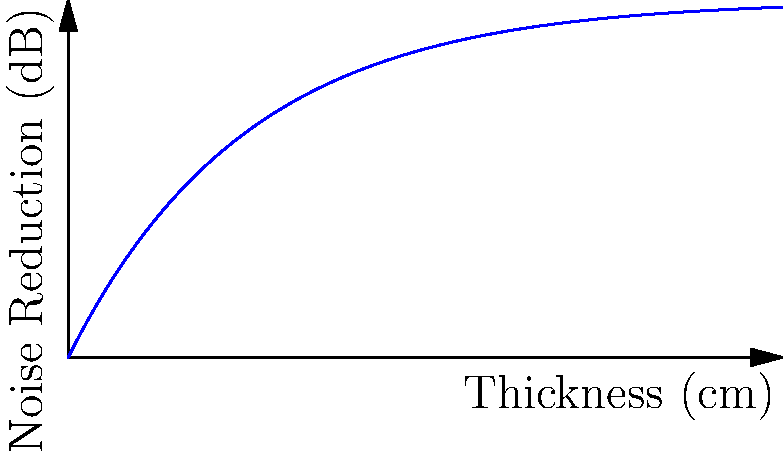A homeowner near a rail crossing wants to optimize their soundproofing. The noise reduction (in dB) achieved by a soundproofing material is given by the function $R(x) = 10(1-e^{-0.2x})$, where $x$ is the thickness of the material in centimeters. The homeowner has a budget that allows for a maximum thickness of 20 cm. What thickness should be used to maximize the rate of noise reduction per unit thickness? To find the optimal thickness, we need to maximize the rate of noise reduction per unit thickness. This is equivalent to finding the point where the second derivative of $R(x)$ is zero.

Step 1: Find the first derivative of $R(x)$.
$R'(x) = 10(0.2e^{-0.2x}) = 2e^{-0.2x}$

Step 2: Find the second derivative of $R(x)$.
$R''(x) = 2(-0.2e^{-0.2x}) = -0.4e^{-0.2x}$

Step 3: Set $R''(x) = 0$ and solve for $x$.
$-0.4e^{-0.2x} = 0$
$e^{-0.2x} = 0$

This equation has no real solution, as $e^{-0.2x}$ is always positive.

Step 4: Analyze the behavior of $R''(x)$.
$R''(x)$ is always negative, which means $R'(x)$ is always decreasing.

Step 5: Conclude that the maximum rate of noise reduction per unit thickness occurs at the smallest possible thickness, which is $x = 0$.

However, since we need some thickness for soundproofing, we should choose the smallest practical thickness, which would be just above 0 cm.
Answer: Just above 0 cm 